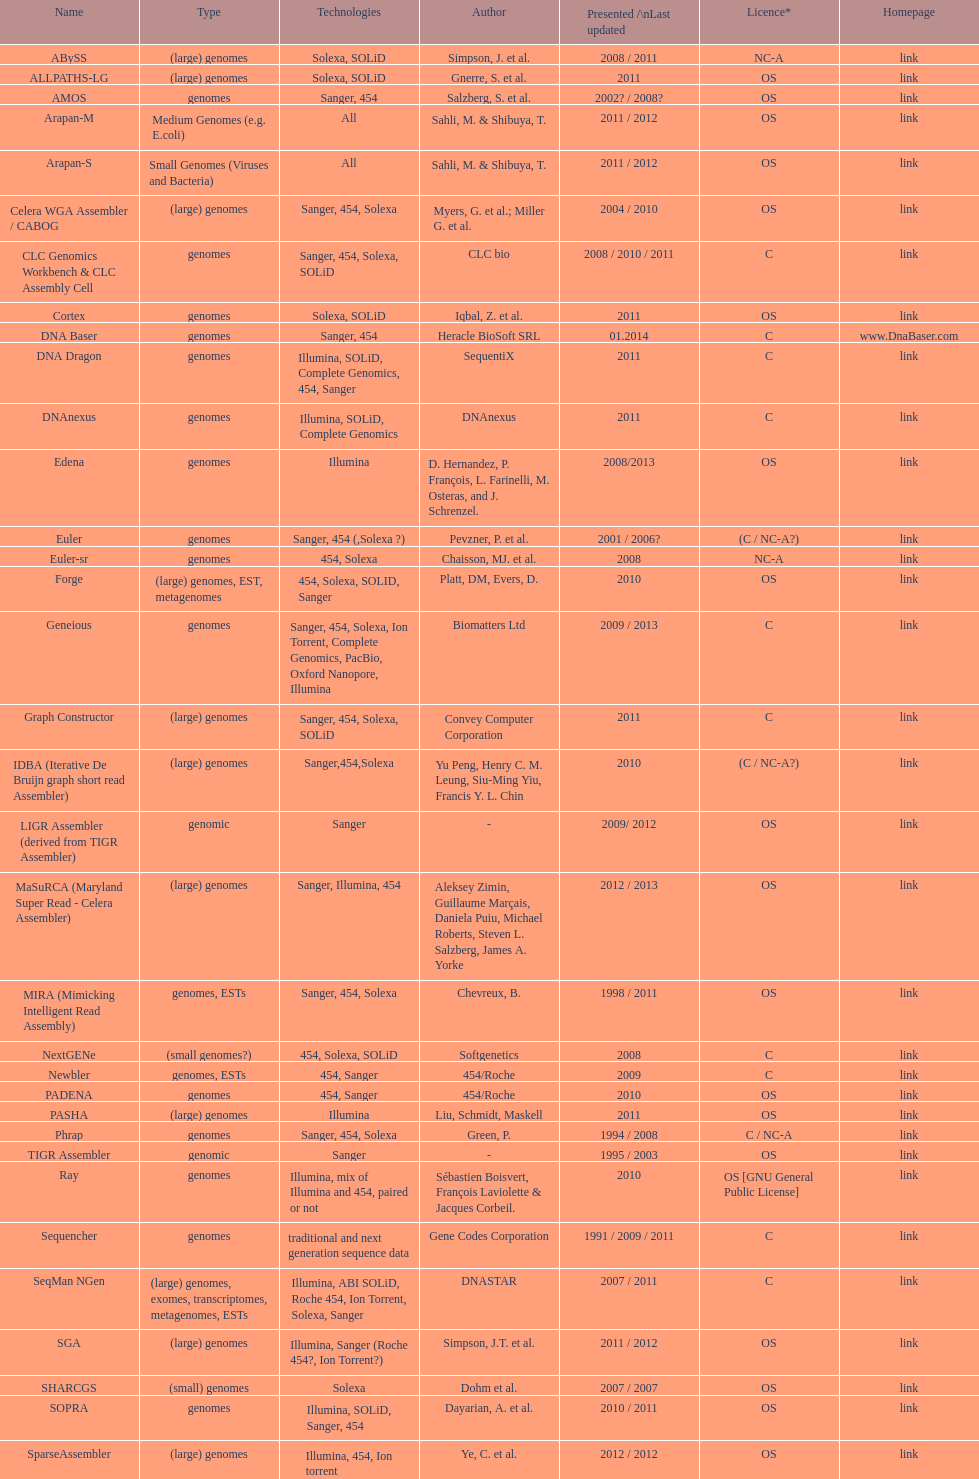What is the latest presentation or updated version? DNA Baser. 